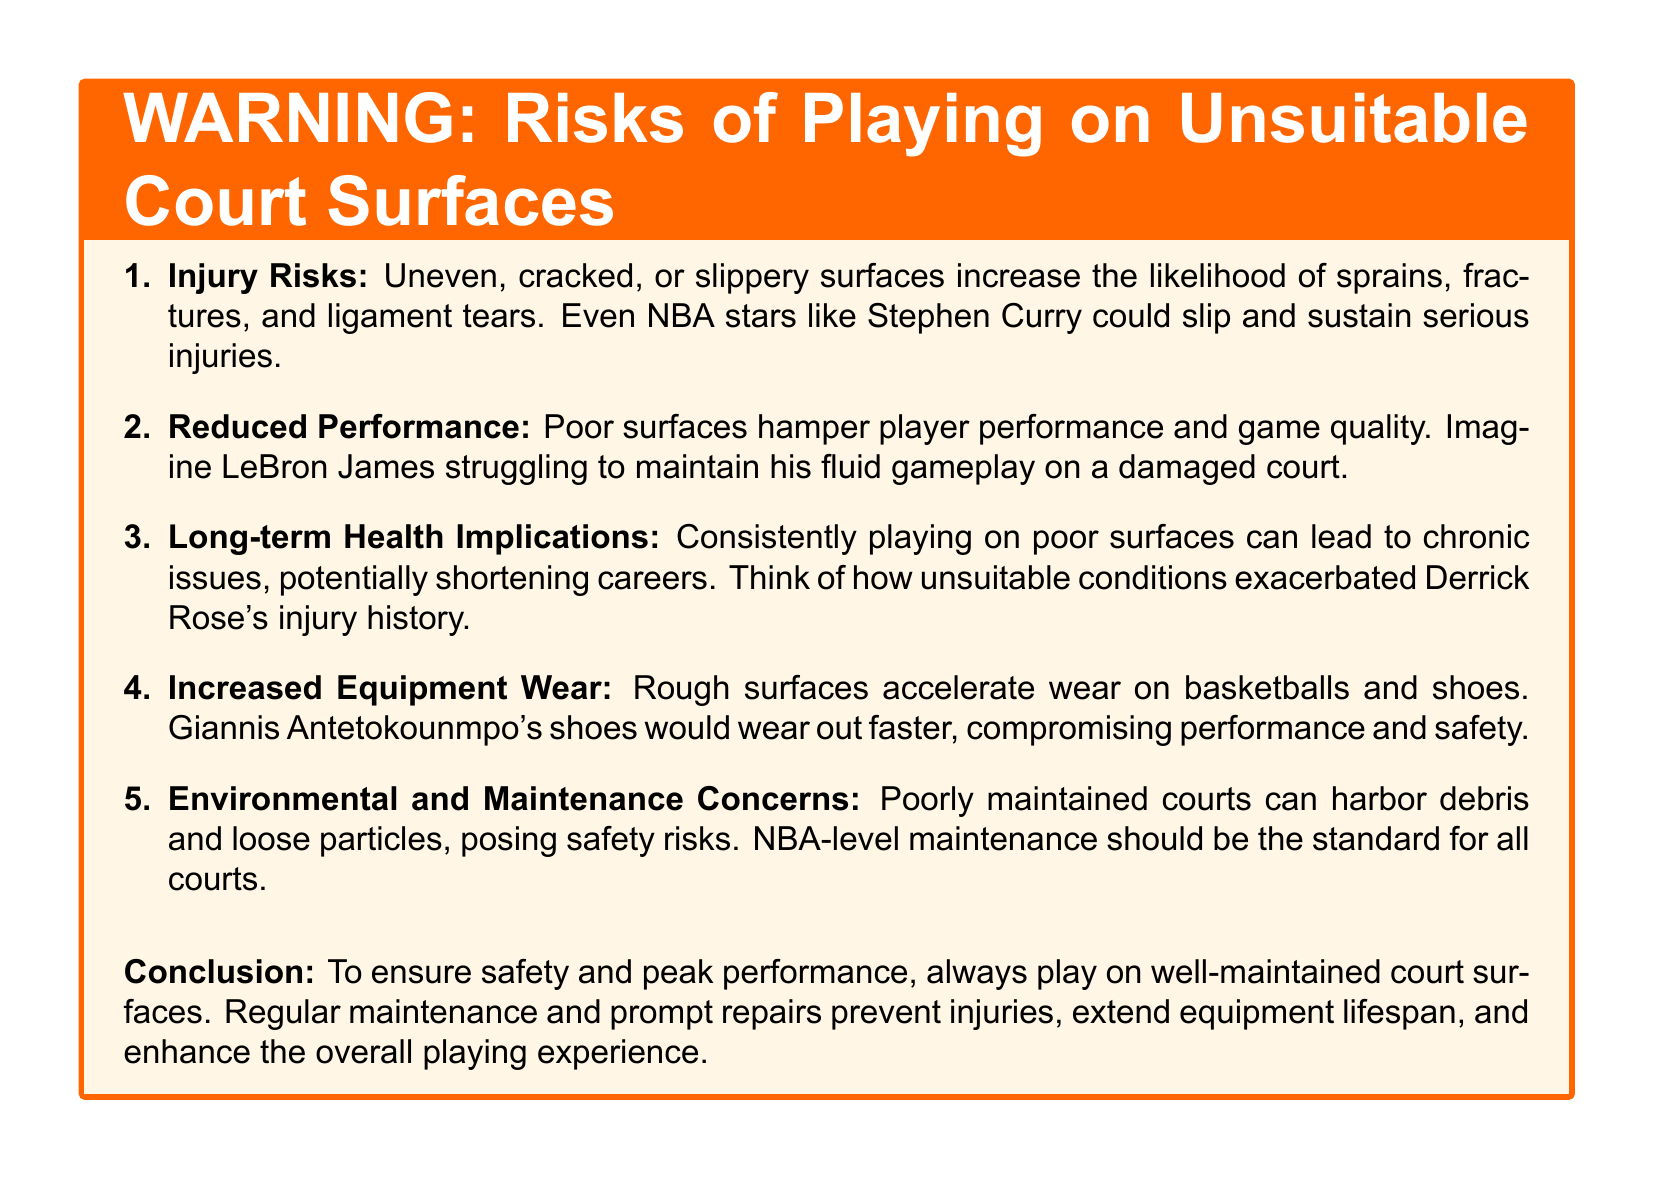what are the types of injury risks? The document lists sprains, fractures, and ligament tears as types of injury risks associated with unsuitable court surfaces.
Answer: sprains, fractures, ligament tears who is mentioned as an example of a player who could sustain injuries? The document mentions Stephen Curry as an example of a player who could slip and sustain serious injuries on unsuitable surfaces.
Answer: Stephen Curry what are the long-term health implications of playing on poor surfaces? The document states that consistently playing on poor surfaces can lead to chronic issues, potentially shortening careers.
Answer: chronic issues, shortened careers what does poor court surface do to player performance? The document indicates that poor surfaces hamper player performance and game quality.
Answer: hamper performance who is referenced in relation to injury history exacerbation? Derrick Rose is referenced in the document regarding how unsuitable conditions exacerbated his injury history.
Answer: Derrick Rose how can rough surfaces affect equipment? The document explains that rough surfaces accelerate wear on basketballs and shoes.
Answer: accelerate wear what should be the standard maintenance for all courts? The document suggests that NBA-level maintenance should be the standard for all courts to ensure safety.
Answer: NBA-level maintenance what is the conclusion regarding court surfaces? The conclusion emphasizes the importance of playing on well-maintained court surfaces for safety and performance.
Answer: well-maintained court surfaces 